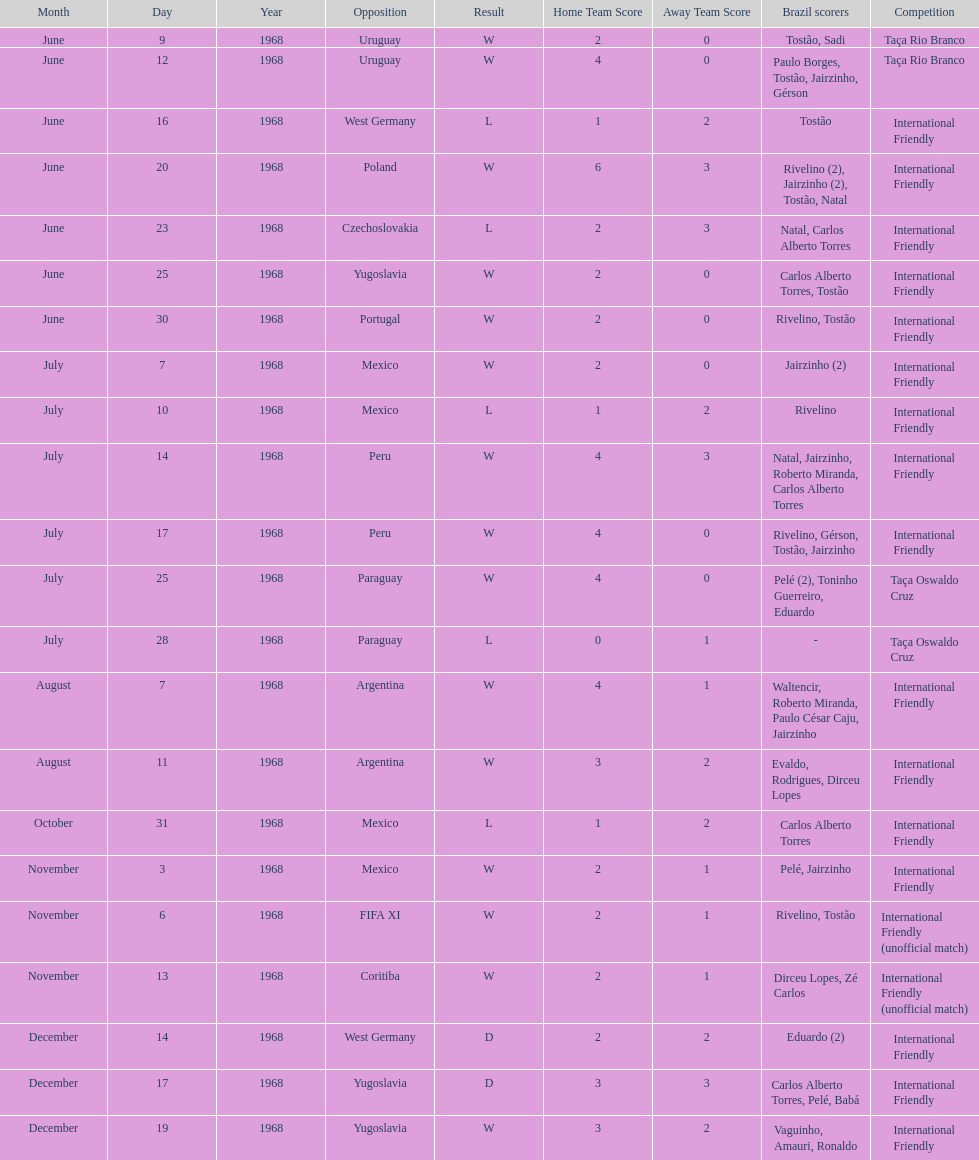What is the top score ever scored by the brazil national team? 6. 